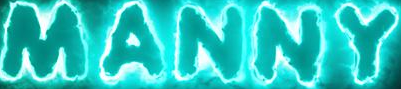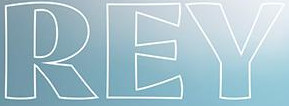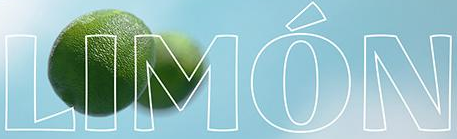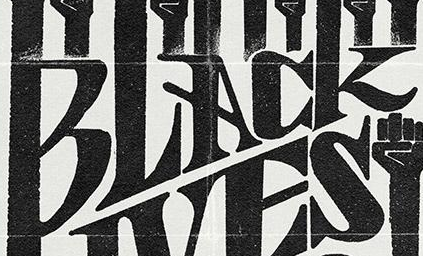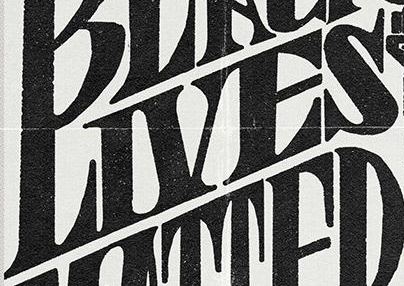What words are shown in these images in order, separated by a semicolon? MANNY; REY; LIMÓN; BLACK; LIVES 